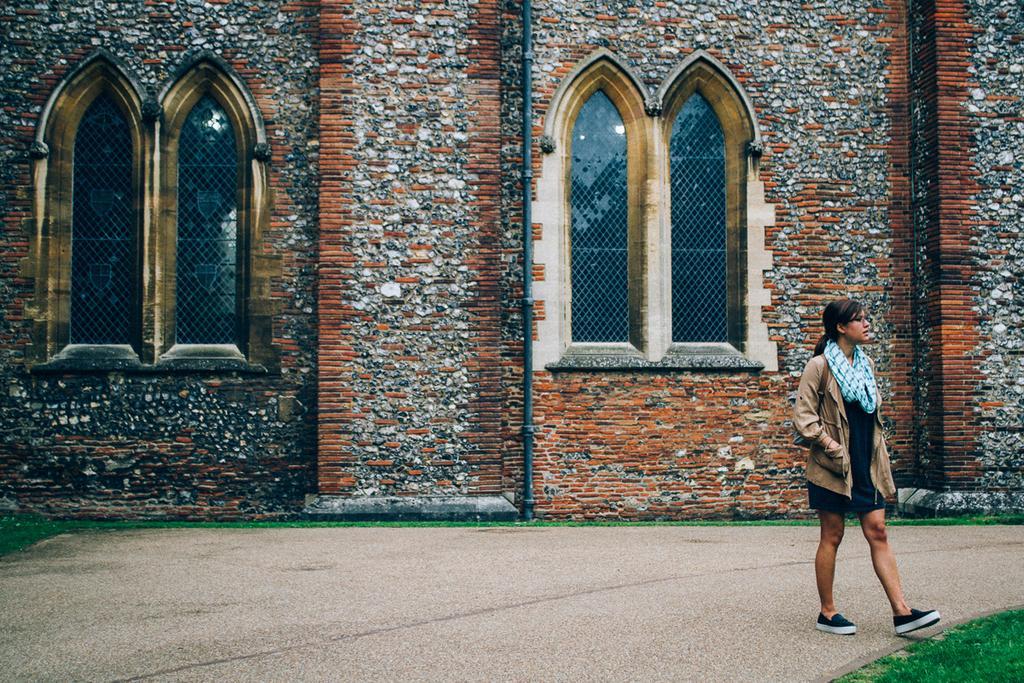How would you summarize this image in a sentence or two? In this image on the right side we can see a woman is walking on the platform. In the background there is a building, windows, pole on the wall and we can see grass on the ground. 